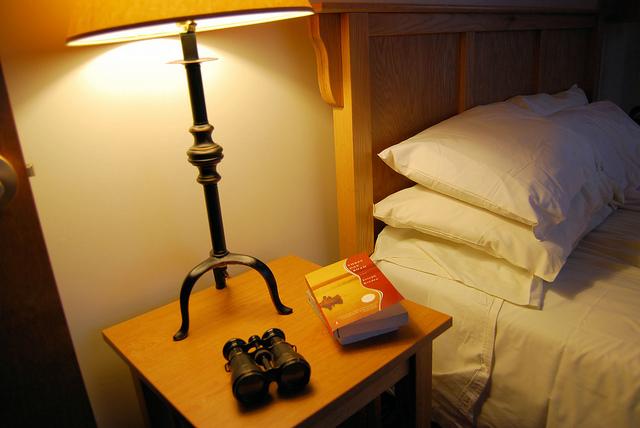Is the light on?
Answer briefly. Yes. How many pillows are there?
Answer briefly. 3. What three objects are on the nightstand?
Write a very short answer. Lamp, binoculars and book. 